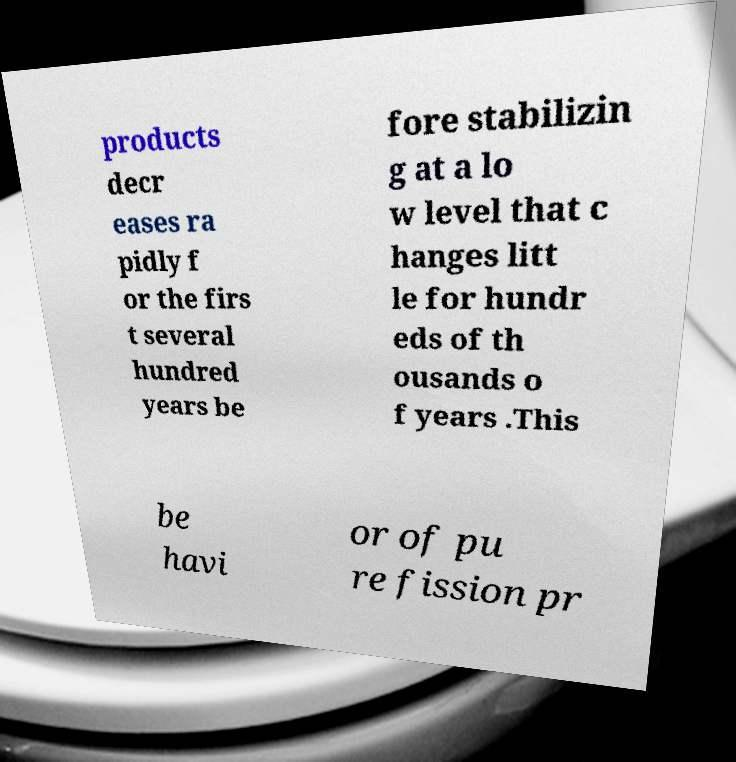Can you read and provide the text displayed in the image?This photo seems to have some interesting text. Can you extract and type it out for me? products decr eases ra pidly f or the firs t several hundred years be fore stabilizin g at a lo w level that c hanges litt le for hundr eds of th ousands o f years .This be havi or of pu re fission pr 